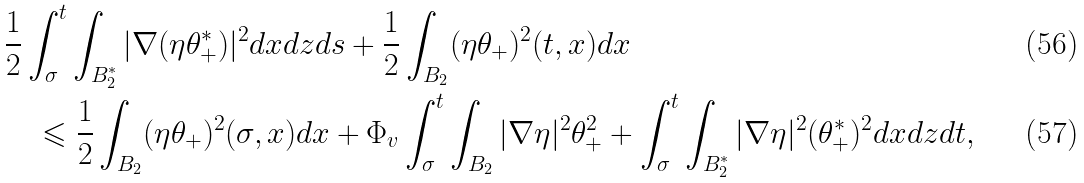Convert formula to latex. <formula><loc_0><loc_0><loc_500><loc_500>& \frac { 1 } { 2 } \int _ { \sigma } ^ { t } \int _ { B _ { 2 } ^ { * } } | \nabla ( \eta \theta _ { + } ^ { * } ) | ^ { 2 } d x d z d s + \frac { 1 } { 2 } \int _ { B _ { 2 } } ( \eta \theta _ { + } ) ^ { 2 } ( t , x ) d x \\ & \quad \leqslant \frac { 1 } { 2 } \int _ { B _ { 2 } } ( \eta \theta _ { + } ) ^ { 2 } ( \sigma , x ) d x + \Phi _ { v } \int _ { \sigma } ^ { t } \int _ { B _ { 2 } } | \nabla \eta | ^ { 2 } \theta _ { + } ^ { 2 } + \int _ { \sigma } ^ { t } \int _ { B _ { 2 } ^ { * } } | \nabla \eta | ^ { 2 } ( \theta _ { + } ^ { * } ) ^ { 2 } d x d z d t ,</formula> 